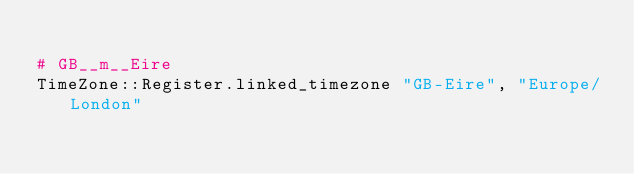Convert code to text. <code><loc_0><loc_0><loc_500><loc_500><_Crystal_>
# GB__m__Eire
TimeZone::Register.linked_timezone "GB-Eire", "Europe/London"
</code> 